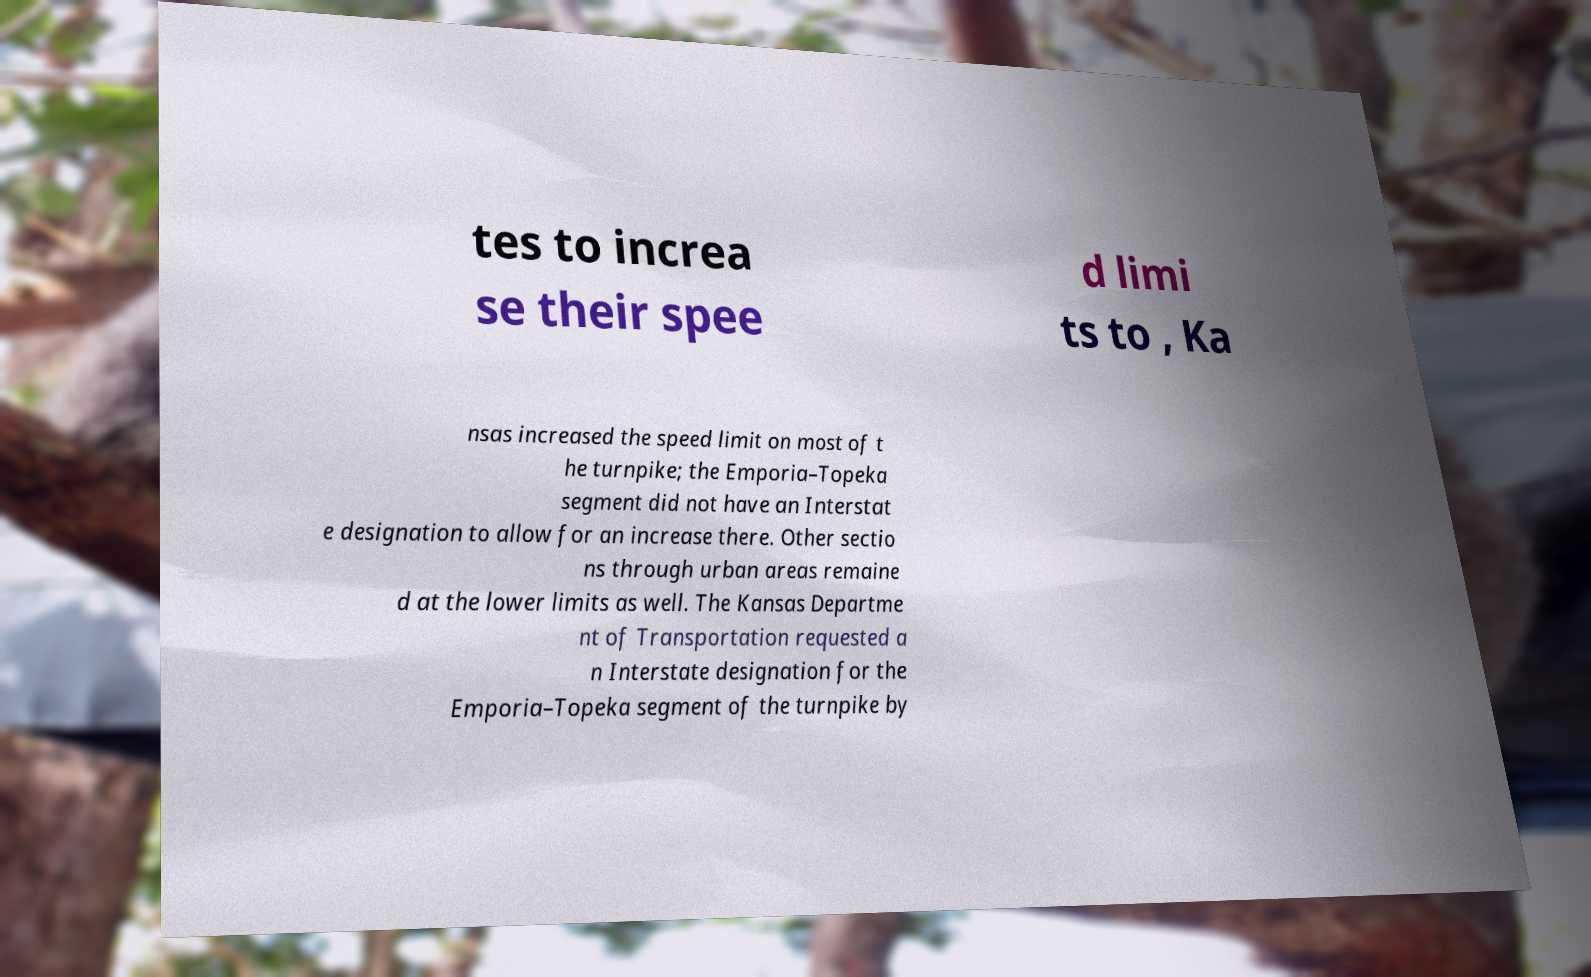Please identify and transcribe the text found in this image. tes to increa se their spee d limi ts to , Ka nsas increased the speed limit on most of t he turnpike; the Emporia–Topeka segment did not have an Interstat e designation to allow for an increase there. Other sectio ns through urban areas remaine d at the lower limits as well. The Kansas Departme nt of Transportation requested a n Interstate designation for the Emporia–Topeka segment of the turnpike by 